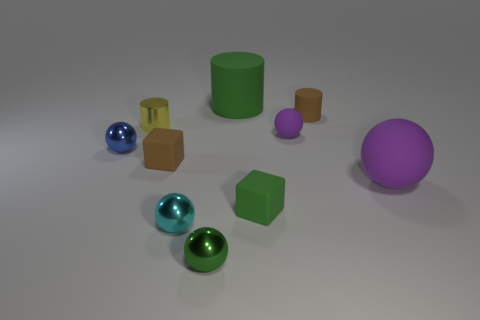Subtract all tiny blue shiny spheres. How many spheres are left? 4 Subtract all blue spheres. How many spheres are left? 4 Subtract all blue spheres. Subtract all yellow cylinders. How many spheres are left? 4 Subtract all cylinders. How many objects are left? 7 Add 8 tiny cyan cubes. How many tiny cyan cubes exist? 8 Subtract 1 green cylinders. How many objects are left? 9 Subtract all purple spheres. Subtract all large green rubber cylinders. How many objects are left? 7 Add 7 cyan spheres. How many cyan spheres are left? 8 